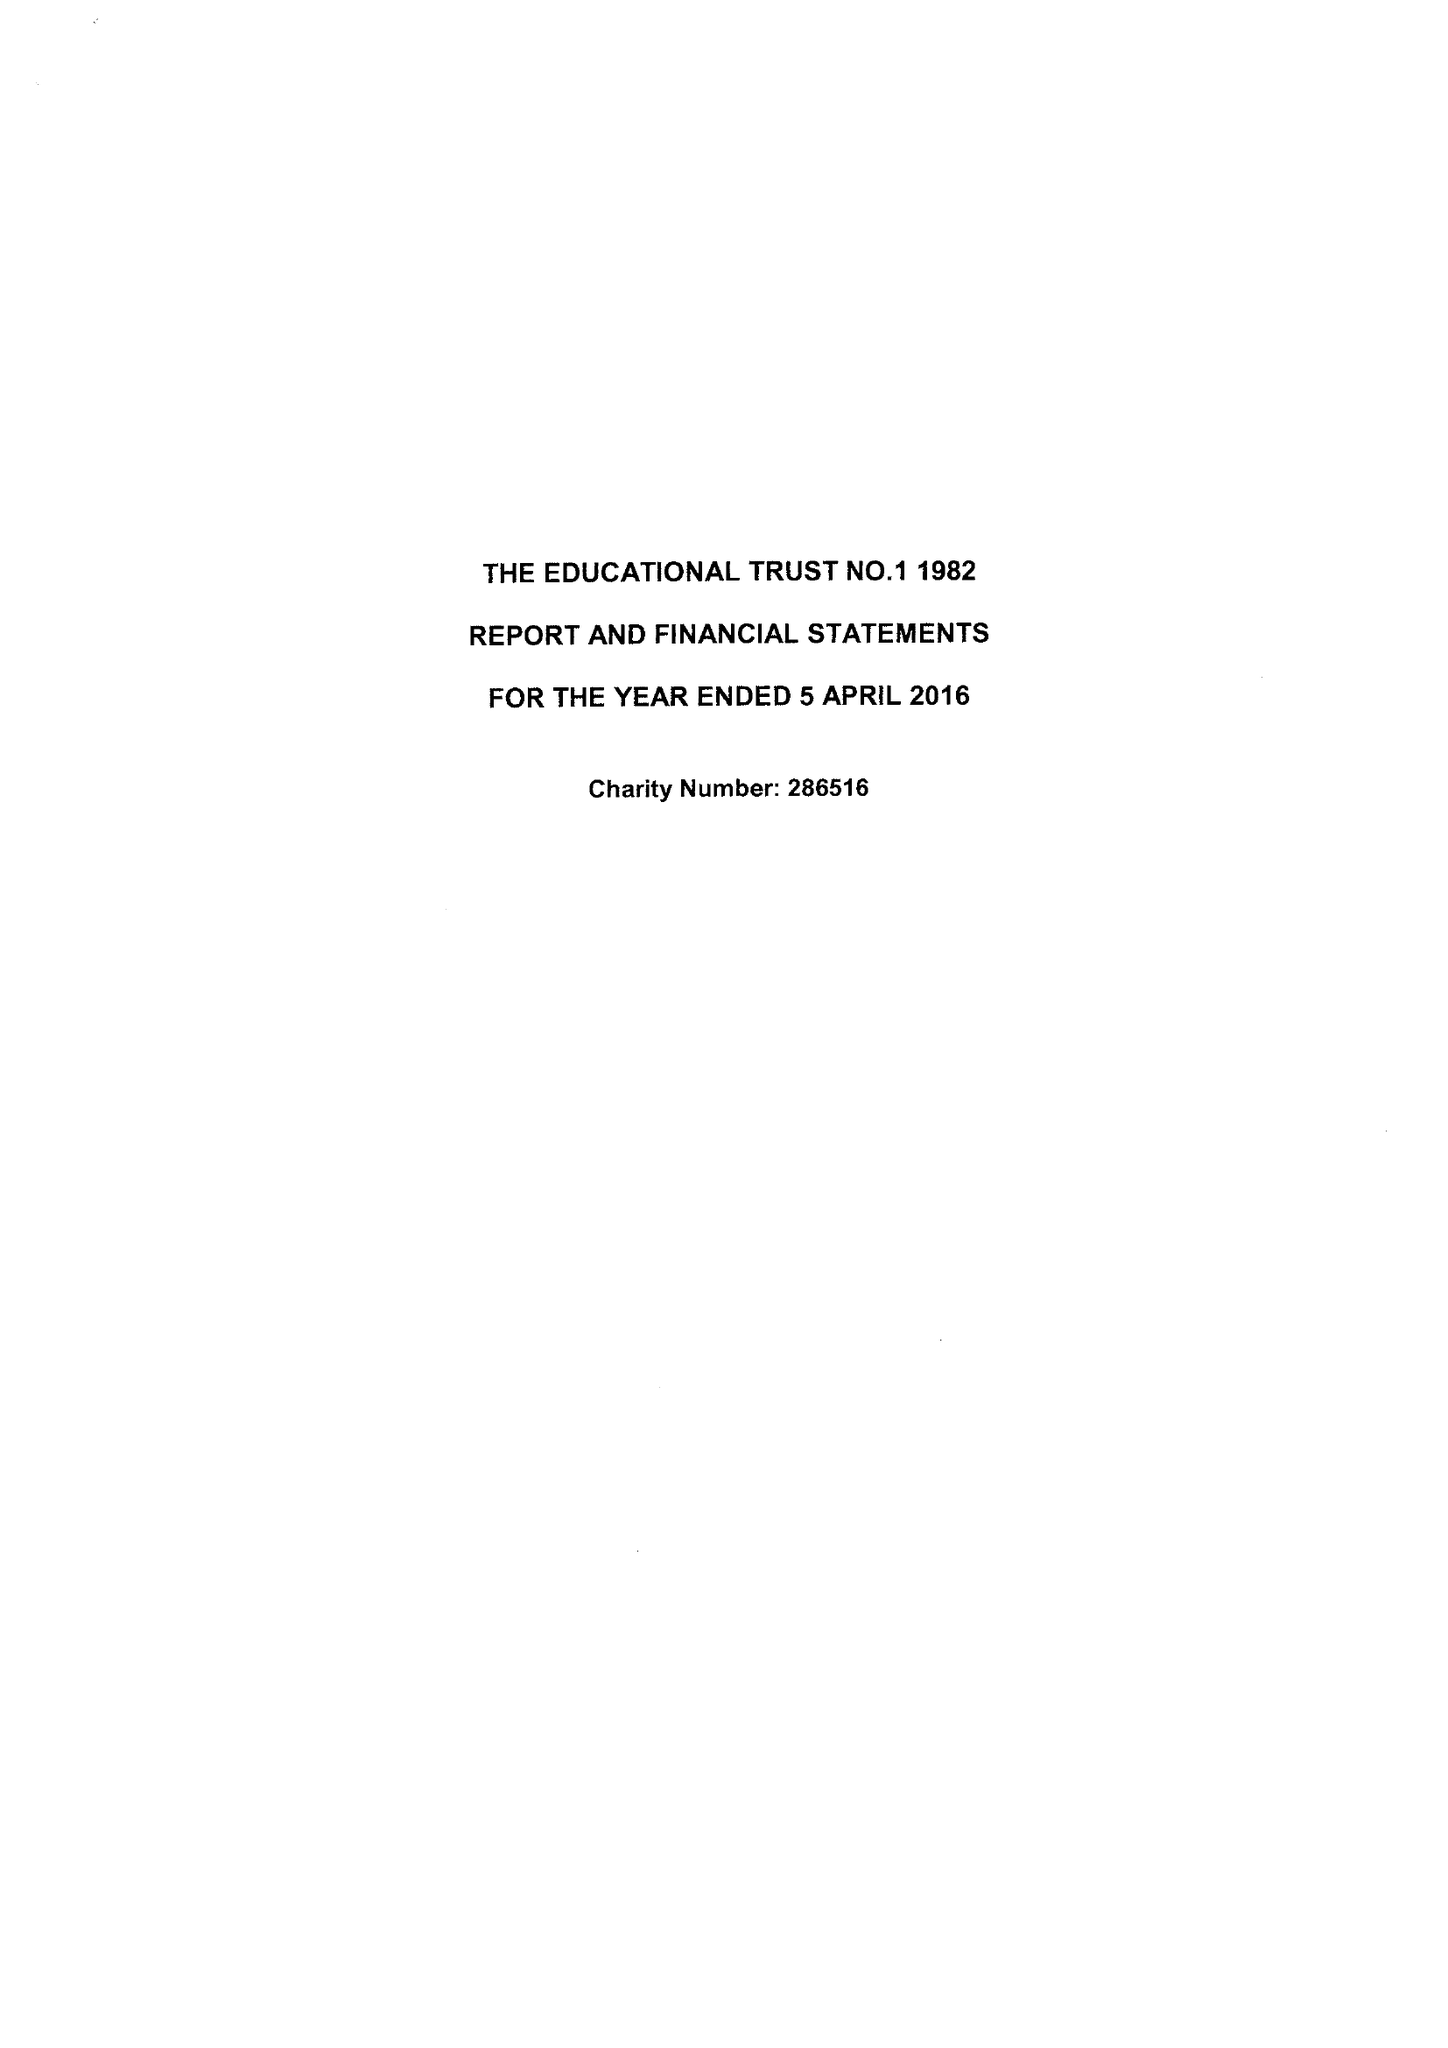What is the value for the spending_annually_in_british_pounds?
Answer the question using a single word or phrase. 857589.00 